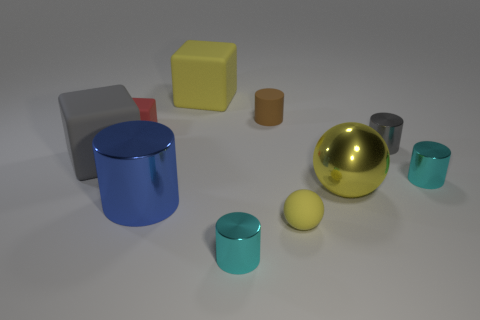Subtract 1 cylinders. How many cylinders are left? 4 Subtract all gray cylinders. How many cylinders are left? 4 Subtract all blue shiny cylinders. How many cylinders are left? 4 Subtract all purple blocks. Subtract all red balls. How many blocks are left? 3 Subtract all spheres. How many objects are left? 8 Add 9 small red rubber spheres. How many small red rubber spheres exist? 9 Subtract 0 purple cylinders. How many objects are left? 10 Subtract all rubber cylinders. Subtract all tiny brown rubber things. How many objects are left? 8 Add 6 big blue objects. How many big blue objects are left? 7 